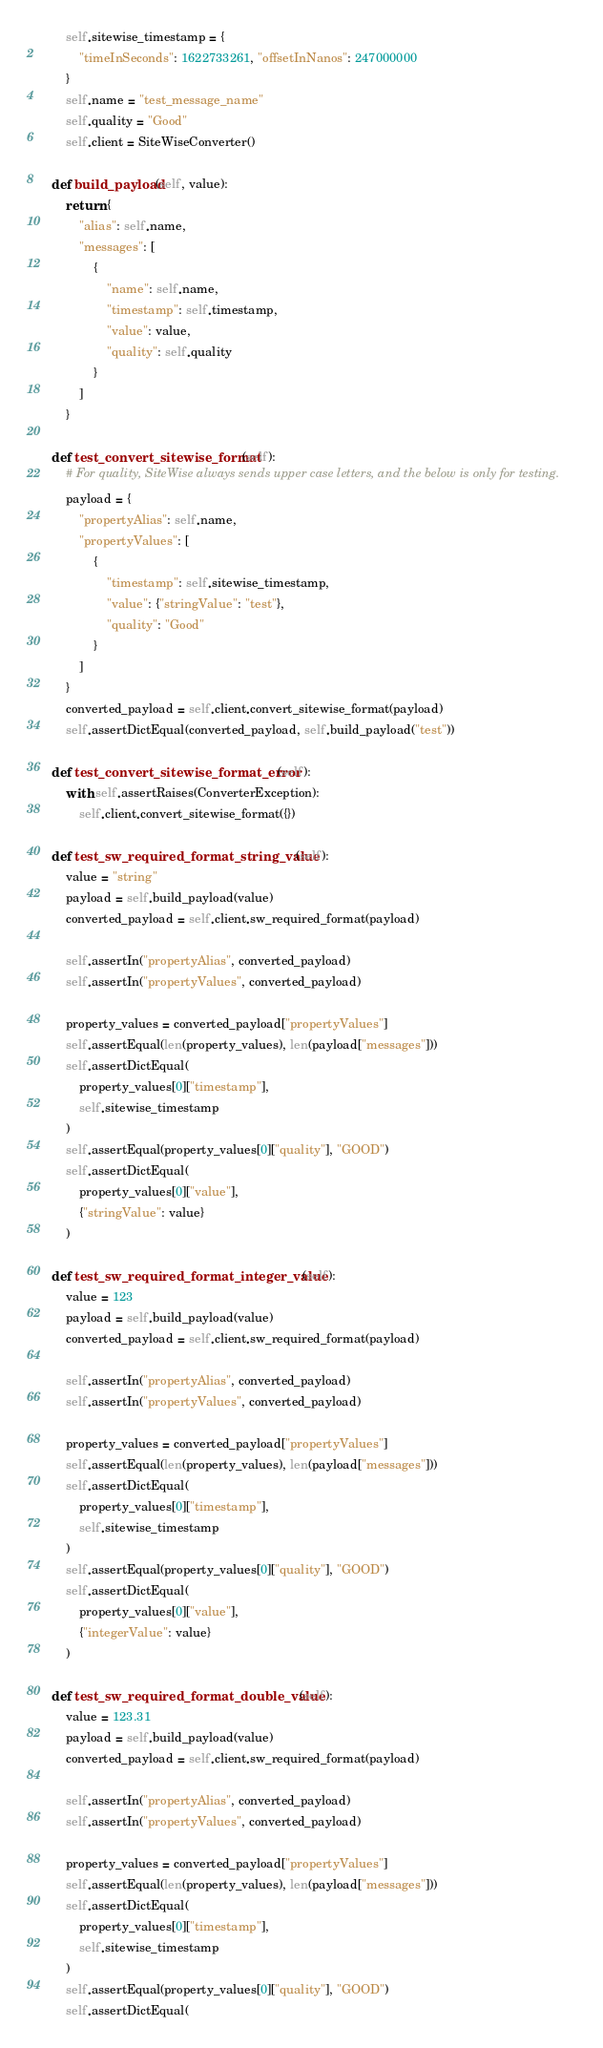Convert code to text. <code><loc_0><loc_0><loc_500><loc_500><_Python_>        self.sitewise_timestamp = {
            "timeInSeconds": 1622733261, "offsetInNanos": 247000000
        }
        self.name = "test_message_name"
        self.quality = "Good"
        self.client = SiteWiseConverter()

    def build_payload(self, value):
        return {
            "alias": self.name,
            "messages": [
                {
                    "name": self.name,
                    "timestamp": self.timestamp,
                    "value": value,
                    "quality": self.quality
                }
            ]
        }

    def test_convert_sitewise_format(self):
        # For quality, SiteWise always sends upper case letters, and the below is only for testing.
        payload = {
            "propertyAlias": self.name,
            "propertyValues": [
                {
                    "timestamp": self.sitewise_timestamp,
                    "value": {"stringValue": "test"},
                    "quality": "Good"
                }
            ]
        }
        converted_payload = self.client.convert_sitewise_format(payload)
        self.assertDictEqual(converted_payload, self.build_payload("test"))

    def test_convert_sitewise_format_error(self):
        with self.assertRaises(ConverterException):
            self.client.convert_sitewise_format({})

    def test_sw_required_format_string_value(self):
        value = "string"
        payload = self.build_payload(value)
        converted_payload = self.client.sw_required_format(payload)

        self.assertIn("propertyAlias", converted_payload)
        self.assertIn("propertyValues", converted_payload)

        property_values = converted_payload["propertyValues"]
        self.assertEqual(len(property_values), len(payload["messages"]))
        self.assertDictEqual(
            property_values[0]["timestamp"],
            self.sitewise_timestamp
        )
        self.assertEqual(property_values[0]["quality"], "GOOD")
        self.assertDictEqual(
            property_values[0]["value"],
            {"stringValue": value}
        )

    def test_sw_required_format_integer_value(self):
        value = 123
        payload = self.build_payload(value)
        converted_payload = self.client.sw_required_format(payload)

        self.assertIn("propertyAlias", converted_payload)
        self.assertIn("propertyValues", converted_payload)

        property_values = converted_payload["propertyValues"]
        self.assertEqual(len(property_values), len(payload["messages"]))
        self.assertDictEqual(
            property_values[0]["timestamp"],
            self.sitewise_timestamp
        )
        self.assertEqual(property_values[0]["quality"], "GOOD")
        self.assertDictEqual(
            property_values[0]["value"],
            {"integerValue": value}
        )

    def test_sw_required_format_double_value(self):
        value = 123.31
        payload = self.build_payload(value)
        converted_payload = self.client.sw_required_format(payload)

        self.assertIn("propertyAlias", converted_payload)
        self.assertIn("propertyValues", converted_payload)

        property_values = converted_payload["propertyValues"]
        self.assertEqual(len(property_values), len(payload["messages"]))
        self.assertDictEqual(
            property_values[0]["timestamp"],
            self.sitewise_timestamp
        )
        self.assertEqual(property_values[0]["quality"], "GOOD")
        self.assertDictEqual(</code> 